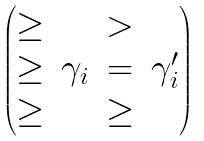Convert formula to latex. <formula><loc_0><loc_0><loc_500><loc_500>\begin{pmatrix} \geq & & > \\ \geq & \gamma _ { i } & = & \gamma ^ { \prime } _ { i } \\ \geq & & \geq \end{pmatrix}</formula> 